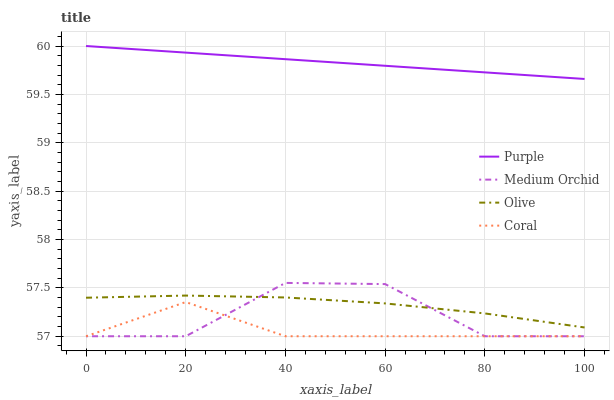Does Coral have the minimum area under the curve?
Answer yes or no. Yes. Does Purple have the maximum area under the curve?
Answer yes or no. Yes. Does Olive have the minimum area under the curve?
Answer yes or no. No. Does Olive have the maximum area under the curve?
Answer yes or no. No. Is Purple the smoothest?
Answer yes or no. Yes. Is Medium Orchid the roughest?
Answer yes or no. Yes. Is Olive the smoothest?
Answer yes or no. No. Is Olive the roughest?
Answer yes or no. No. Does Coral have the lowest value?
Answer yes or no. Yes. Does Olive have the lowest value?
Answer yes or no. No. Does Purple have the highest value?
Answer yes or no. Yes. Does Olive have the highest value?
Answer yes or no. No. Is Olive less than Purple?
Answer yes or no. Yes. Is Purple greater than Olive?
Answer yes or no. Yes. Does Coral intersect Medium Orchid?
Answer yes or no. Yes. Is Coral less than Medium Orchid?
Answer yes or no. No. Is Coral greater than Medium Orchid?
Answer yes or no. No. Does Olive intersect Purple?
Answer yes or no. No. 